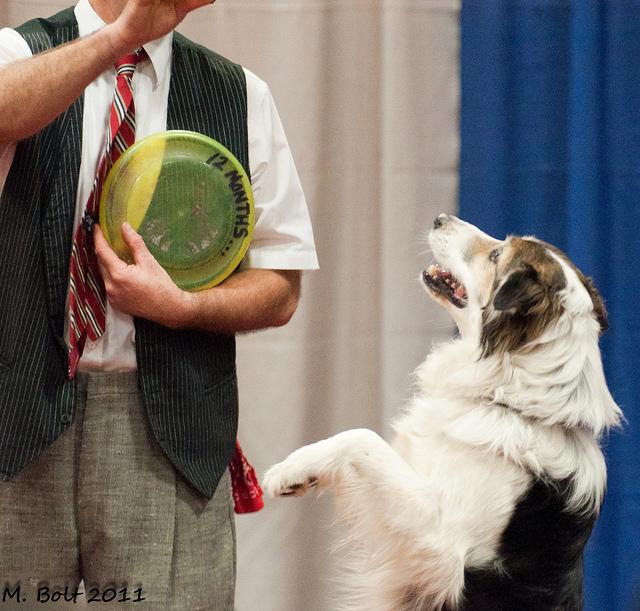Is the man wearing jeans?
Give a very brief answer. No. What does the dog want to do?
Write a very short answer. Play. In what year was this picture taken?
Keep it brief. 2011. 